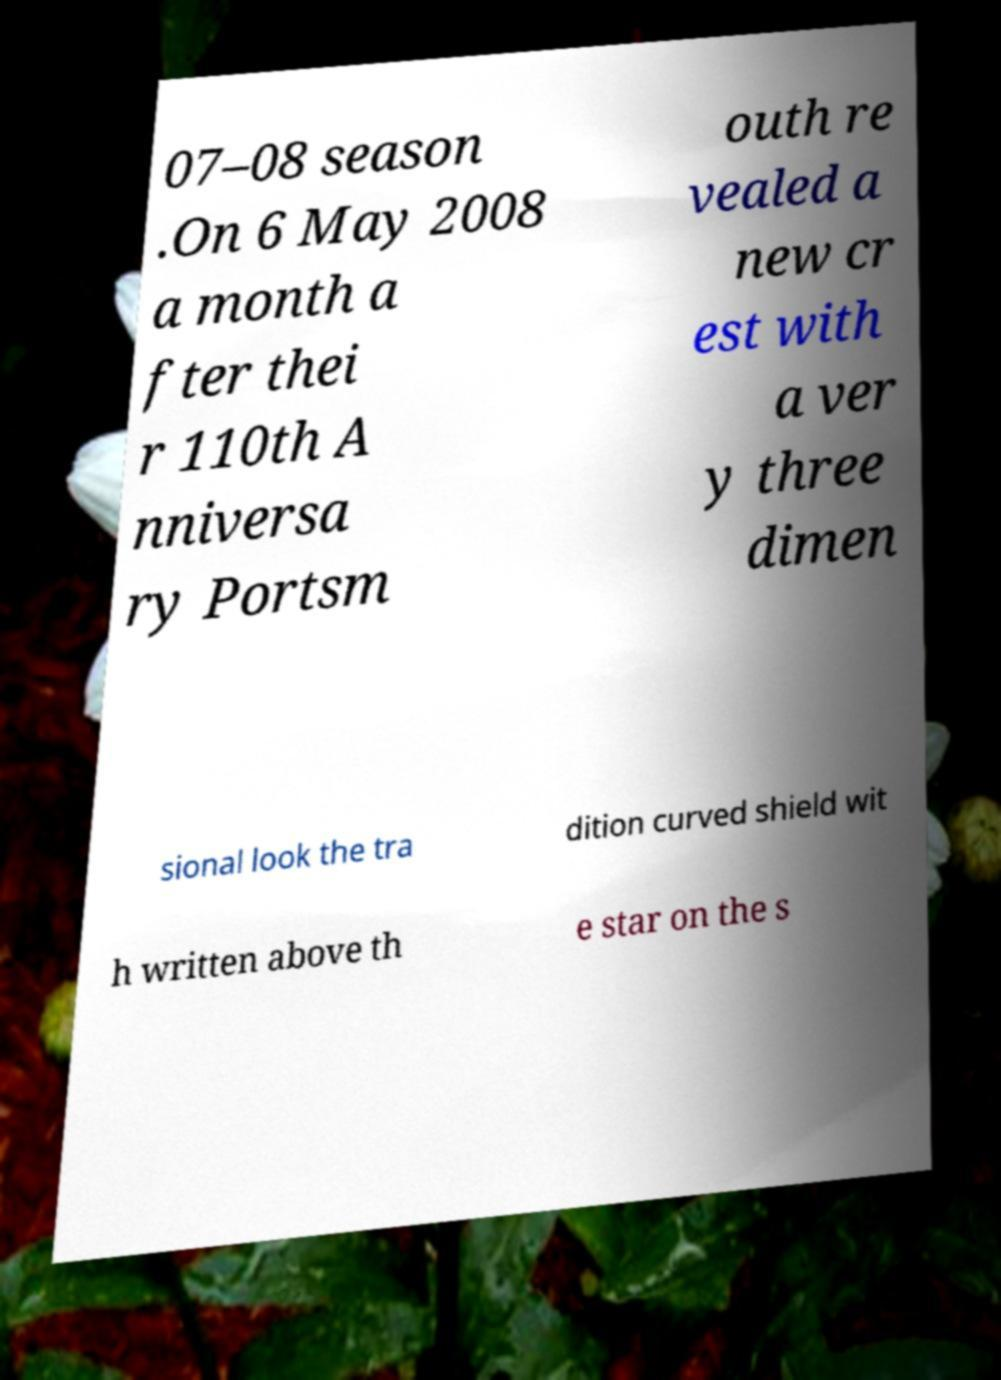Could you assist in decoding the text presented in this image and type it out clearly? 07–08 season .On 6 May 2008 a month a fter thei r 110th A nniversa ry Portsm outh re vealed a new cr est with a ver y three dimen sional look the tra dition curved shield wit h written above th e star on the s 